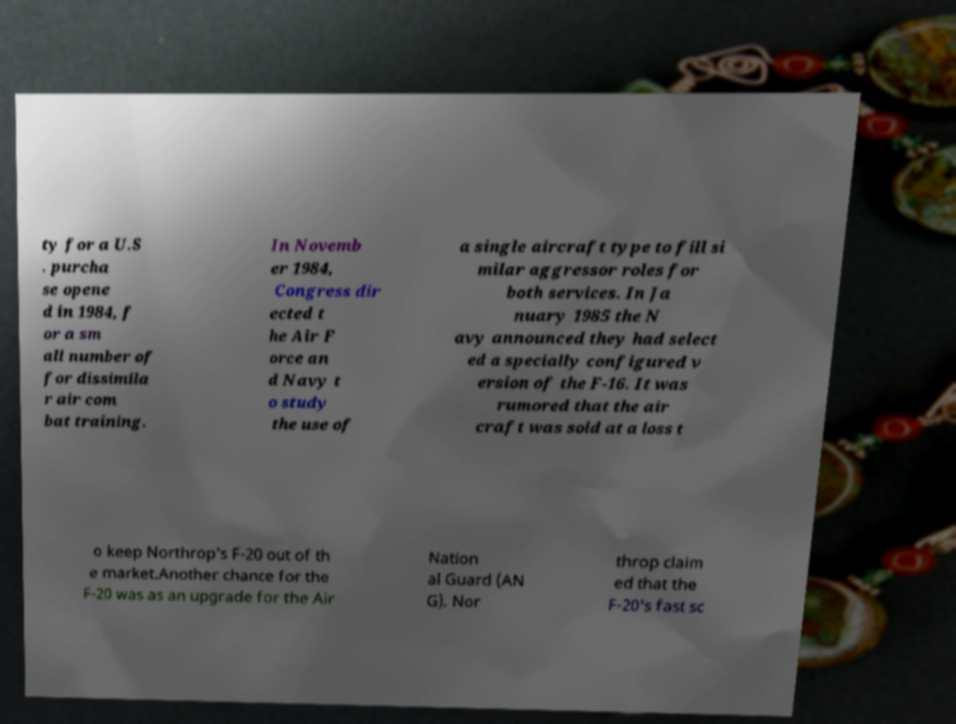What messages or text are displayed in this image? I need them in a readable, typed format. ty for a U.S . purcha se opene d in 1984, f or a sm all number of for dissimila r air com bat training. In Novemb er 1984, Congress dir ected t he Air F orce an d Navy t o study the use of a single aircraft type to fill si milar aggressor roles for both services. In Ja nuary 1985 the N avy announced they had select ed a specially configured v ersion of the F-16. It was rumored that the air craft was sold at a loss t o keep Northrop's F-20 out of th e market.Another chance for the F-20 was as an upgrade for the Air Nation al Guard (AN G). Nor throp claim ed that the F-20's fast sc 